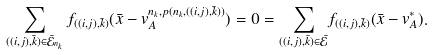<formula> <loc_0><loc_0><loc_500><loc_500>\sum _ { ( ( i , j ) , \bar { k } ) \in \bar { \mathcal { E } } _ { n _ { k } } } f _ { ( ( i , j ) , \bar { k } ) } ( \bar { x } - { v } _ { A } ^ { n _ { k } , p ( n _ { k } , ( ( i , j ) , \bar { k } ) ) } ) = 0 = \underset { ( ( i , j ) , \bar { k } ) \in \bar { \mathcal { E } } } { { \sum } } f _ { ( ( i , j ) , \bar { k } ) } ( \bar { x } - { v } _ { A } ^ { * } ) .</formula> 